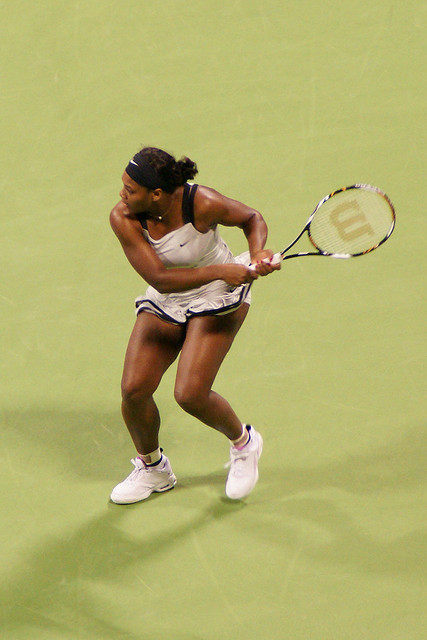Read and extract the text from this image. E 